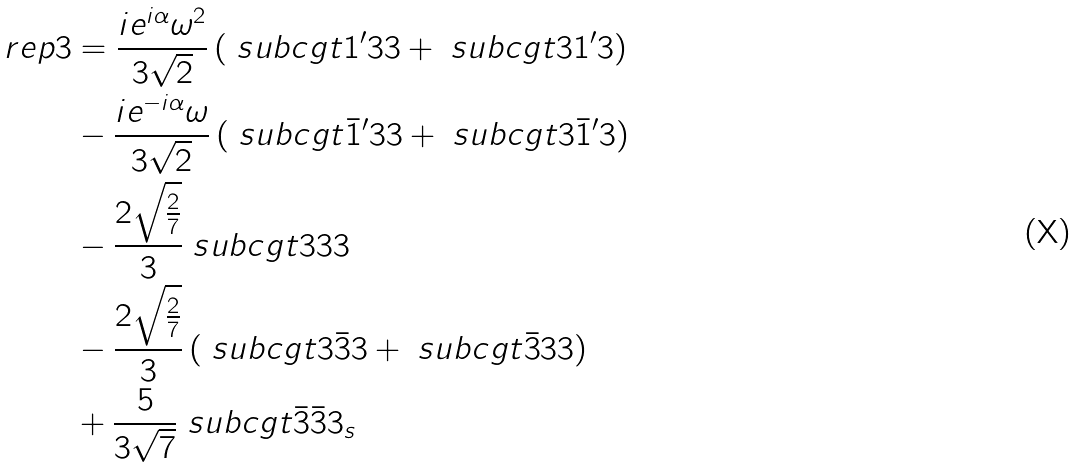Convert formula to latex. <formula><loc_0><loc_0><loc_500><loc_500>\ r e p { 3 } & = \frac { i e ^ { i \alpha } \omega ^ { 2 } } { 3 \sqrt { 2 } } \left ( \ s u b c g t { 1 ^ { \prime } } { 3 } { 3 } + \ s u b c g t { 3 } { 1 ^ { \prime } } { 3 } \right ) \\ & - \frac { i e ^ { - i \alpha } \omega } { 3 \sqrt { 2 } } \left ( \ s u b c g t { \bar { 1 } ^ { \prime } } { 3 } { 3 } + \ s u b c g t { 3 } { \bar { 1 } ^ { \prime } } { 3 } \right ) \\ & - \frac { 2 \sqrt { \frac { 2 } { 7 } } } { 3 } \ s u b c g t { 3 } { 3 } { 3 } \\ & - \frac { 2 \sqrt { \frac { 2 } { 7 } } } { 3 } \left ( \ s u b c g t { 3 } { \bar { 3 } } { 3 } + \ s u b c g t { \bar { 3 } } { 3 } { 3 } \right ) \\ & + \frac { 5 } { 3 \sqrt { 7 } } \ s u b c g t { \bar { 3 } } { \bar { 3 } } { 3 _ { s } }</formula> 